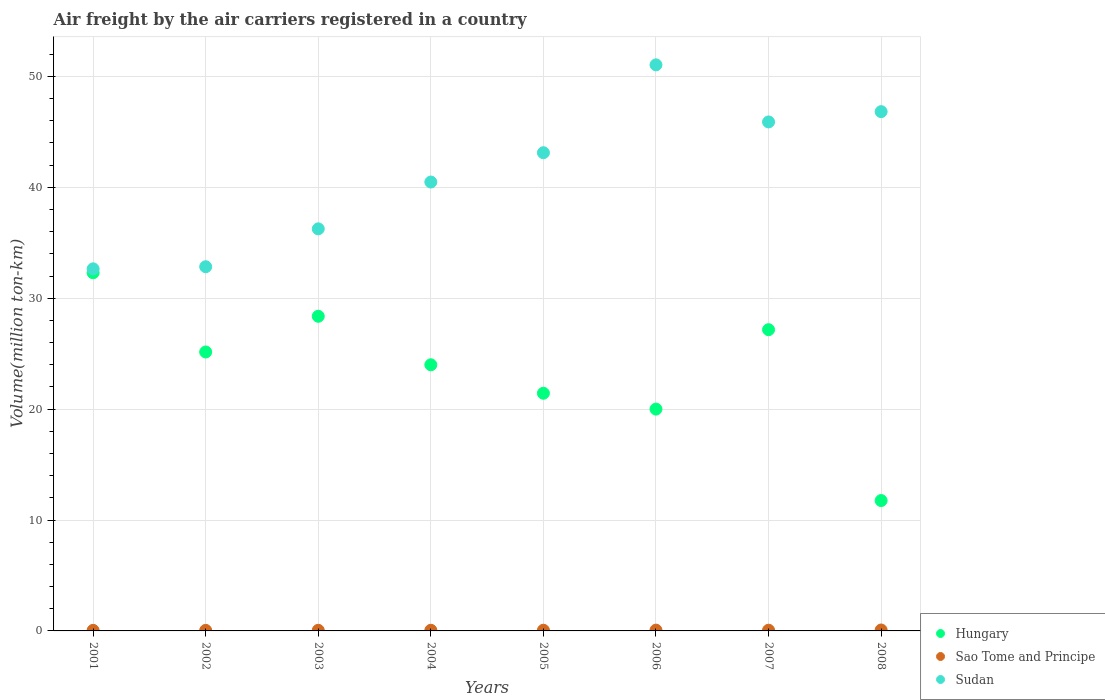What is the volume of the air carriers in Hungary in 2005?
Provide a succinct answer. 21.43. Across all years, what is the maximum volume of the air carriers in Sudan?
Offer a terse response. 51.04. Across all years, what is the minimum volume of the air carriers in Hungary?
Your answer should be compact. 11.76. In which year was the volume of the air carriers in Sudan minimum?
Ensure brevity in your answer.  2001. What is the total volume of the air carriers in Hungary in the graph?
Your response must be concise. 190.16. What is the difference between the volume of the air carriers in Hungary in 2002 and that in 2006?
Provide a succinct answer. 5.15. What is the difference between the volume of the air carriers in Hungary in 2006 and the volume of the air carriers in Sudan in 2003?
Provide a short and direct response. -16.25. What is the average volume of the air carriers in Hungary per year?
Give a very brief answer. 23.77. In the year 2001, what is the difference between the volume of the air carriers in Hungary and volume of the air carriers in Sao Tome and Principe?
Offer a terse response. 32.24. What is the ratio of the volume of the air carriers in Sao Tome and Principe in 2001 to that in 2005?
Your answer should be very brief. 0.82. Is the difference between the volume of the air carriers in Hungary in 2001 and 2007 greater than the difference between the volume of the air carriers in Sao Tome and Principe in 2001 and 2007?
Your response must be concise. Yes. What is the difference between the highest and the second highest volume of the air carriers in Hungary?
Keep it short and to the point. 3.92. What is the difference between the highest and the lowest volume of the air carriers in Sudan?
Offer a terse response. 18.39. Is the sum of the volume of the air carriers in Sudan in 2004 and 2008 greater than the maximum volume of the air carriers in Sao Tome and Principe across all years?
Make the answer very short. Yes. Does the volume of the air carriers in Sudan monotonically increase over the years?
Provide a short and direct response. No. Is the volume of the air carriers in Sudan strictly less than the volume of the air carriers in Hungary over the years?
Provide a succinct answer. No. How many dotlines are there?
Your answer should be very brief. 3. How many years are there in the graph?
Provide a short and direct response. 8. What is the difference between two consecutive major ticks on the Y-axis?
Your response must be concise. 10. Are the values on the major ticks of Y-axis written in scientific E-notation?
Give a very brief answer. No. Where does the legend appear in the graph?
Offer a terse response. Bottom right. How many legend labels are there?
Provide a short and direct response. 3. What is the title of the graph?
Make the answer very short. Air freight by the air carriers registered in a country. What is the label or title of the X-axis?
Your answer should be very brief. Years. What is the label or title of the Y-axis?
Provide a succinct answer. Volume(million ton-km). What is the Volume(million ton-km) of Hungary in 2001?
Ensure brevity in your answer.  32.29. What is the Volume(million ton-km) in Sao Tome and Principe in 2001?
Offer a very short reply. 0.05. What is the Volume(million ton-km) of Sudan in 2001?
Ensure brevity in your answer.  32.65. What is the Volume(million ton-km) of Hungary in 2002?
Give a very brief answer. 25.15. What is the Volume(million ton-km) of Sao Tome and Principe in 2002?
Your answer should be very brief. 0.05. What is the Volume(million ton-km) of Sudan in 2002?
Provide a succinct answer. 32.84. What is the Volume(million ton-km) in Hungary in 2003?
Provide a short and direct response. 28.37. What is the Volume(million ton-km) in Sao Tome and Principe in 2003?
Offer a very short reply. 0.06. What is the Volume(million ton-km) of Sudan in 2003?
Give a very brief answer. 36.25. What is the Volume(million ton-km) in Hungary in 2004?
Your response must be concise. 24. What is the Volume(million ton-km) in Sao Tome and Principe in 2004?
Your answer should be compact. 0.06. What is the Volume(million ton-km) of Sudan in 2004?
Keep it short and to the point. 40.47. What is the Volume(million ton-km) of Hungary in 2005?
Your answer should be compact. 21.43. What is the Volume(million ton-km) of Sao Tome and Principe in 2005?
Make the answer very short. 0.06. What is the Volume(million ton-km) in Sudan in 2005?
Your answer should be compact. 43.12. What is the Volume(million ton-km) of Sao Tome and Principe in 2006?
Offer a terse response. 0.07. What is the Volume(million ton-km) of Sudan in 2006?
Make the answer very short. 51.04. What is the Volume(million ton-km) in Hungary in 2007?
Ensure brevity in your answer.  27.16. What is the Volume(million ton-km) of Sao Tome and Principe in 2007?
Offer a very short reply. 0.06. What is the Volume(million ton-km) in Sudan in 2007?
Ensure brevity in your answer.  45.89. What is the Volume(million ton-km) in Hungary in 2008?
Your response must be concise. 11.76. What is the Volume(million ton-km) of Sao Tome and Principe in 2008?
Give a very brief answer. 0.08. What is the Volume(million ton-km) in Sudan in 2008?
Give a very brief answer. 46.82. Across all years, what is the maximum Volume(million ton-km) in Hungary?
Offer a very short reply. 32.29. Across all years, what is the maximum Volume(million ton-km) of Sao Tome and Principe?
Provide a succinct answer. 0.08. Across all years, what is the maximum Volume(million ton-km) in Sudan?
Make the answer very short. 51.04. Across all years, what is the minimum Volume(million ton-km) of Hungary?
Your answer should be very brief. 11.76. Across all years, what is the minimum Volume(million ton-km) of Sao Tome and Principe?
Make the answer very short. 0.05. Across all years, what is the minimum Volume(million ton-km) of Sudan?
Offer a very short reply. 32.65. What is the total Volume(million ton-km) in Hungary in the graph?
Provide a short and direct response. 190.16. What is the total Volume(million ton-km) in Sao Tome and Principe in the graph?
Offer a terse response. 0.5. What is the total Volume(million ton-km) in Sudan in the graph?
Ensure brevity in your answer.  329.08. What is the difference between the Volume(million ton-km) in Hungary in 2001 and that in 2002?
Give a very brief answer. 7.14. What is the difference between the Volume(million ton-km) in Sao Tome and Principe in 2001 and that in 2002?
Ensure brevity in your answer.  0. What is the difference between the Volume(million ton-km) in Sudan in 2001 and that in 2002?
Make the answer very short. -0.19. What is the difference between the Volume(million ton-km) of Hungary in 2001 and that in 2003?
Keep it short and to the point. 3.92. What is the difference between the Volume(million ton-km) in Sao Tome and Principe in 2001 and that in 2003?
Offer a very short reply. -0.01. What is the difference between the Volume(million ton-km) in Sudan in 2001 and that in 2003?
Provide a succinct answer. -3.61. What is the difference between the Volume(million ton-km) in Hungary in 2001 and that in 2004?
Your answer should be very brief. 8.3. What is the difference between the Volume(million ton-km) in Sao Tome and Principe in 2001 and that in 2004?
Provide a succinct answer. -0.01. What is the difference between the Volume(million ton-km) of Sudan in 2001 and that in 2004?
Your response must be concise. -7.83. What is the difference between the Volume(million ton-km) of Hungary in 2001 and that in 2005?
Keep it short and to the point. 10.87. What is the difference between the Volume(million ton-km) in Sao Tome and Principe in 2001 and that in 2005?
Make the answer very short. -0.01. What is the difference between the Volume(million ton-km) of Sudan in 2001 and that in 2005?
Your answer should be compact. -10.47. What is the difference between the Volume(million ton-km) of Hungary in 2001 and that in 2006?
Keep it short and to the point. 12.29. What is the difference between the Volume(million ton-km) in Sao Tome and Principe in 2001 and that in 2006?
Give a very brief answer. -0.02. What is the difference between the Volume(million ton-km) of Sudan in 2001 and that in 2006?
Your answer should be very brief. -18.39. What is the difference between the Volume(million ton-km) in Hungary in 2001 and that in 2007?
Make the answer very short. 5.13. What is the difference between the Volume(million ton-km) in Sao Tome and Principe in 2001 and that in 2007?
Ensure brevity in your answer.  -0.01. What is the difference between the Volume(million ton-km) in Sudan in 2001 and that in 2007?
Your answer should be very brief. -13.24. What is the difference between the Volume(million ton-km) in Hungary in 2001 and that in 2008?
Make the answer very short. 20.54. What is the difference between the Volume(million ton-km) in Sao Tome and Principe in 2001 and that in 2008?
Provide a succinct answer. -0.03. What is the difference between the Volume(million ton-km) of Sudan in 2001 and that in 2008?
Make the answer very short. -14.17. What is the difference between the Volume(million ton-km) of Hungary in 2002 and that in 2003?
Provide a succinct answer. -3.22. What is the difference between the Volume(million ton-km) in Sao Tome and Principe in 2002 and that in 2003?
Provide a short and direct response. -0.01. What is the difference between the Volume(million ton-km) in Sudan in 2002 and that in 2003?
Provide a short and direct response. -3.42. What is the difference between the Volume(million ton-km) of Hungary in 2002 and that in 2004?
Make the answer very short. 1.16. What is the difference between the Volume(million ton-km) in Sao Tome and Principe in 2002 and that in 2004?
Provide a short and direct response. -0.01. What is the difference between the Volume(million ton-km) of Sudan in 2002 and that in 2004?
Your answer should be very brief. -7.64. What is the difference between the Volume(million ton-km) of Hungary in 2002 and that in 2005?
Offer a terse response. 3.72. What is the difference between the Volume(million ton-km) in Sao Tome and Principe in 2002 and that in 2005?
Provide a short and direct response. -0.01. What is the difference between the Volume(million ton-km) in Sudan in 2002 and that in 2005?
Your answer should be very brief. -10.28. What is the difference between the Volume(million ton-km) of Hungary in 2002 and that in 2006?
Your response must be concise. 5.15. What is the difference between the Volume(million ton-km) in Sao Tome and Principe in 2002 and that in 2006?
Keep it short and to the point. -0.02. What is the difference between the Volume(million ton-km) of Sudan in 2002 and that in 2006?
Provide a short and direct response. -18.2. What is the difference between the Volume(million ton-km) in Hungary in 2002 and that in 2007?
Provide a succinct answer. -2.01. What is the difference between the Volume(million ton-km) in Sao Tome and Principe in 2002 and that in 2007?
Offer a very short reply. -0.01. What is the difference between the Volume(million ton-km) in Sudan in 2002 and that in 2007?
Your response must be concise. -13.05. What is the difference between the Volume(million ton-km) of Hungary in 2002 and that in 2008?
Ensure brevity in your answer.  13.4. What is the difference between the Volume(million ton-km) of Sao Tome and Principe in 2002 and that in 2008?
Ensure brevity in your answer.  -0.03. What is the difference between the Volume(million ton-km) in Sudan in 2002 and that in 2008?
Provide a short and direct response. -13.98. What is the difference between the Volume(million ton-km) in Hungary in 2003 and that in 2004?
Offer a very short reply. 4.37. What is the difference between the Volume(million ton-km) in Sao Tome and Principe in 2003 and that in 2004?
Provide a succinct answer. -0. What is the difference between the Volume(million ton-km) of Sudan in 2003 and that in 2004?
Provide a short and direct response. -4.22. What is the difference between the Volume(million ton-km) of Hungary in 2003 and that in 2005?
Offer a terse response. 6.94. What is the difference between the Volume(million ton-km) in Sao Tome and Principe in 2003 and that in 2005?
Make the answer very short. -0.01. What is the difference between the Volume(million ton-km) in Sudan in 2003 and that in 2005?
Make the answer very short. -6.86. What is the difference between the Volume(million ton-km) in Hungary in 2003 and that in 2006?
Your answer should be very brief. 8.37. What is the difference between the Volume(million ton-km) in Sao Tome and Principe in 2003 and that in 2006?
Offer a terse response. -0.01. What is the difference between the Volume(million ton-km) of Sudan in 2003 and that in 2006?
Your response must be concise. -14.79. What is the difference between the Volume(million ton-km) of Hungary in 2003 and that in 2007?
Offer a very short reply. 1.21. What is the difference between the Volume(million ton-km) in Sao Tome and Principe in 2003 and that in 2007?
Your answer should be very brief. -0.01. What is the difference between the Volume(million ton-km) in Sudan in 2003 and that in 2007?
Keep it short and to the point. -9.64. What is the difference between the Volume(million ton-km) of Hungary in 2003 and that in 2008?
Your answer should be compact. 16.61. What is the difference between the Volume(million ton-km) of Sao Tome and Principe in 2003 and that in 2008?
Keep it short and to the point. -0.03. What is the difference between the Volume(million ton-km) in Sudan in 2003 and that in 2008?
Give a very brief answer. -10.57. What is the difference between the Volume(million ton-km) of Hungary in 2004 and that in 2005?
Offer a terse response. 2.57. What is the difference between the Volume(million ton-km) in Sao Tome and Principe in 2004 and that in 2005?
Make the answer very short. -0. What is the difference between the Volume(million ton-km) of Sudan in 2004 and that in 2005?
Make the answer very short. -2.64. What is the difference between the Volume(million ton-km) of Hungary in 2004 and that in 2006?
Offer a very short reply. 4. What is the difference between the Volume(million ton-km) in Sao Tome and Principe in 2004 and that in 2006?
Your answer should be compact. -0.01. What is the difference between the Volume(million ton-km) in Sudan in 2004 and that in 2006?
Your response must be concise. -10.57. What is the difference between the Volume(million ton-km) of Hungary in 2004 and that in 2007?
Provide a short and direct response. -3.17. What is the difference between the Volume(million ton-km) of Sao Tome and Principe in 2004 and that in 2007?
Give a very brief answer. -0.01. What is the difference between the Volume(million ton-km) of Sudan in 2004 and that in 2007?
Ensure brevity in your answer.  -5.42. What is the difference between the Volume(million ton-km) in Hungary in 2004 and that in 2008?
Provide a short and direct response. 12.24. What is the difference between the Volume(million ton-km) of Sao Tome and Principe in 2004 and that in 2008?
Offer a terse response. -0.03. What is the difference between the Volume(million ton-km) of Sudan in 2004 and that in 2008?
Your answer should be compact. -6.35. What is the difference between the Volume(million ton-km) in Hungary in 2005 and that in 2006?
Give a very brief answer. 1.43. What is the difference between the Volume(million ton-km) in Sao Tome and Principe in 2005 and that in 2006?
Offer a terse response. -0.01. What is the difference between the Volume(million ton-km) of Sudan in 2005 and that in 2006?
Make the answer very short. -7.92. What is the difference between the Volume(million ton-km) in Hungary in 2005 and that in 2007?
Provide a short and direct response. -5.73. What is the difference between the Volume(million ton-km) of Sao Tome and Principe in 2005 and that in 2007?
Offer a very short reply. -0. What is the difference between the Volume(million ton-km) in Sudan in 2005 and that in 2007?
Provide a short and direct response. -2.77. What is the difference between the Volume(million ton-km) in Hungary in 2005 and that in 2008?
Keep it short and to the point. 9.67. What is the difference between the Volume(million ton-km) in Sao Tome and Principe in 2005 and that in 2008?
Give a very brief answer. -0.02. What is the difference between the Volume(million ton-km) of Sudan in 2005 and that in 2008?
Give a very brief answer. -3.7. What is the difference between the Volume(million ton-km) of Hungary in 2006 and that in 2007?
Provide a short and direct response. -7.16. What is the difference between the Volume(million ton-km) in Sao Tome and Principe in 2006 and that in 2007?
Ensure brevity in your answer.  0.01. What is the difference between the Volume(million ton-km) of Sudan in 2006 and that in 2007?
Your answer should be very brief. 5.15. What is the difference between the Volume(million ton-km) of Hungary in 2006 and that in 2008?
Give a very brief answer. 8.24. What is the difference between the Volume(million ton-km) in Sao Tome and Principe in 2006 and that in 2008?
Ensure brevity in your answer.  -0.01. What is the difference between the Volume(million ton-km) in Sudan in 2006 and that in 2008?
Make the answer very short. 4.22. What is the difference between the Volume(million ton-km) of Hungary in 2007 and that in 2008?
Your answer should be very brief. 15.41. What is the difference between the Volume(million ton-km) in Sao Tome and Principe in 2007 and that in 2008?
Offer a very short reply. -0.02. What is the difference between the Volume(million ton-km) in Sudan in 2007 and that in 2008?
Offer a very short reply. -0.93. What is the difference between the Volume(million ton-km) in Hungary in 2001 and the Volume(million ton-km) in Sao Tome and Principe in 2002?
Give a very brief answer. 32.24. What is the difference between the Volume(million ton-km) of Hungary in 2001 and the Volume(million ton-km) of Sudan in 2002?
Ensure brevity in your answer.  -0.54. What is the difference between the Volume(million ton-km) in Sao Tome and Principe in 2001 and the Volume(million ton-km) in Sudan in 2002?
Keep it short and to the point. -32.79. What is the difference between the Volume(million ton-km) of Hungary in 2001 and the Volume(million ton-km) of Sao Tome and Principe in 2003?
Your answer should be very brief. 32.24. What is the difference between the Volume(million ton-km) of Hungary in 2001 and the Volume(million ton-km) of Sudan in 2003?
Your answer should be compact. -3.96. What is the difference between the Volume(million ton-km) in Sao Tome and Principe in 2001 and the Volume(million ton-km) in Sudan in 2003?
Provide a short and direct response. -36.2. What is the difference between the Volume(million ton-km) in Hungary in 2001 and the Volume(million ton-km) in Sao Tome and Principe in 2004?
Make the answer very short. 32.23. What is the difference between the Volume(million ton-km) in Hungary in 2001 and the Volume(million ton-km) in Sudan in 2004?
Your response must be concise. -8.18. What is the difference between the Volume(million ton-km) of Sao Tome and Principe in 2001 and the Volume(million ton-km) of Sudan in 2004?
Make the answer very short. -40.42. What is the difference between the Volume(million ton-km) in Hungary in 2001 and the Volume(million ton-km) in Sao Tome and Principe in 2005?
Provide a succinct answer. 32.23. What is the difference between the Volume(million ton-km) in Hungary in 2001 and the Volume(million ton-km) in Sudan in 2005?
Offer a very short reply. -10.82. What is the difference between the Volume(million ton-km) of Sao Tome and Principe in 2001 and the Volume(million ton-km) of Sudan in 2005?
Your response must be concise. -43.07. What is the difference between the Volume(million ton-km) in Hungary in 2001 and the Volume(million ton-km) in Sao Tome and Principe in 2006?
Offer a very short reply. 32.22. What is the difference between the Volume(million ton-km) in Hungary in 2001 and the Volume(million ton-km) in Sudan in 2006?
Make the answer very short. -18.75. What is the difference between the Volume(million ton-km) of Sao Tome and Principe in 2001 and the Volume(million ton-km) of Sudan in 2006?
Offer a very short reply. -50.99. What is the difference between the Volume(million ton-km) of Hungary in 2001 and the Volume(million ton-km) of Sao Tome and Principe in 2007?
Offer a terse response. 32.23. What is the difference between the Volume(million ton-km) in Hungary in 2001 and the Volume(million ton-km) in Sudan in 2007?
Offer a terse response. -13.6. What is the difference between the Volume(million ton-km) in Sao Tome and Principe in 2001 and the Volume(million ton-km) in Sudan in 2007?
Your answer should be compact. -45.84. What is the difference between the Volume(million ton-km) of Hungary in 2001 and the Volume(million ton-km) of Sao Tome and Principe in 2008?
Make the answer very short. 32.21. What is the difference between the Volume(million ton-km) in Hungary in 2001 and the Volume(million ton-km) in Sudan in 2008?
Provide a short and direct response. -14.53. What is the difference between the Volume(million ton-km) in Sao Tome and Principe in 2001 and the Volume(million ton-km) in Sudan in 2008?
Provide a short and direct response. -46.77. What is the difference between the Volume(million ton-km) in Hungary in 2002 and the Volume(million ton-km) in Sao Tome and Principe in 2003?
Give a very brief answer. 25.09. What is the difference between the Volume(million ton-km) in Hungary in 2002 and the Volume(million ton-km) in Sudan in 2003?
Your answer should be compact. -11.1. What is the difference between the Volume(million ton-km) of Sao Tome and Principe in 2002 and the Volume(million ton-km) of Sudan in 2003?
Provide a short and direct response. -36.2. What is the difference between the Volume(million ton-km) of Hungary in 2002 and the Volume(million ton-km) of Sao Tome and Principe in 2004?
Your answer should be very brief. 25.09. What is the difference between the Volume(million ton-km) of Hungary in 2002 and the Volume(million ton-km) of Sudan in 2004?
Keep it short and to the point. -15.32. What is the difference between the Volume(million ton-km) of Sao Tome and Principe in 2002 and the Volume(million ton-km) of Sudan in 2004?
Offer a terse response. -40.42. What is the difference between the Volume(million ton-km) in Hungary in 2002 and the Volume(million ton-km) in Sao Tome and Principe in 2005?
Offer a very short reply. 25.09. What is the difference between the Volume(million ton-km) of Hungary in 2002 and the Volume(million ton-km) of Sudan in 2005?
Give a very brief answer. -17.97. What is the difference between the Volume(million ton-km) of Sao Tome and Principe in 2002 and the Volume(million ton-km) of Sudan in 2005?
Keep it short and to the point. -43.07. What is the difference between the Volume(million ton-km) in Hungary in 2002 and the Volume(million ton-km) in Sao Tome and Principe in 2006?
Give a very brief answer. 25.08. What is the difference between the Volume(million ton-km) of Hungary in 2002 and the Volume(million ton-km) of Sudan in 2006?
Your answer should be very brief. -25.89. What is the difference between the Volume(million ton-km) of Sao Tome and Principe in 2002 and the Volume(million ton-km) of Sudan in 2006?
Your answer should be compact. -50.99. What is the difference between the Volume(million ton-km) of Hungary in 2002 and the Volume(million ton-km) of Sao Tome and Principe in 2007?
Ensure brevity in your answer.  25.09. What is the difference between the Volume(million ton-km) in Hungary in 2002 and the Volume(million ton-km) in Sudan in 2007?
Give a very brief answer. -20.74. What is the difference between the Volume(million ton-km) in Sao Tome and Principe in 2002 and the Volume(million ton-km) in Sudan in 2007?
Ensure brevity in your answer.  -45.84. What is the difference between the Volume(million ton-km) in Hungary in 2002 and the Volume(million ton-km) in Sao Tome and Principe in 2008?
Give a very brief answer. 25.07. What is the difference between the Volume(million ton-km) of Hungary in 2002 and the Volume(million ton-km) of Sudan in 2008?
Provide a succinct answer. -21.67. What is the difference between the Volume(million ton-km) of Sao Tome and Principe in 2002 and the Volume(million ton-km) of Sudan in 2008?
Ensure brevity in your answer.  -46.77. What is the difference between the Volume(million ton-km) of Hungary in 2003 and the Volume(million ton-km) of Sao Tome and Principe in 2004?
Provide a succinct answer. 28.31. What is the difference between the Volume(million ton-km) of Hungary in 2003 and the Volume(million ton-km) of Sudan in 2004?
Offer a terse response. -12.1. What is the difference between the Volume(million ton-km) of Sao Tome and Principe in 2003 and the Volume(million ton-km) of Sudan in 2004?
Make the answer very short. -40.42. What is the difference between the Volume(million ton-km) in Hungary in 2003 and the Volume(million ton-km) in Sao Tome and Principe in 2005?
Provide a succinct answer. 28.31. What is the difference between the Volume(million ton-km) of Hungary in 2003 and the Volume(million ton-km) of Sudan in 2005?
Offer a terse response. -14.75. What is the difference between the Volume(million ton-km) of Sao Tome and Principe in 2003 and the Volume(million ton-km) of Sudan in 2005?
Provide a short and direct response. -43.06. What is the difference between the Volume(million ton-km) in Hungary in 2003 and the Volume(million ton-km) in Sao Tome and Principe in 2006?
Your response must be concise. 28.3. What is the difference between the Volume(million ton-km) of Hungary in 2003 and the Volume(million ton-km) of Sudan in 2006?
Provide a short and direct response. -22.67. What is the difference between the Volume(million ton-km) in Sao Tome and Principe in 2003 and the Volume(million ton-km) in Sudan in 2006?
Give a very brief answer. -50.98. What is the difference between the Volume(million ton-km) of Hungary in 2003 and the Volume(million ton-km) of Sao Tome and Principe in 2007?
Give a very brief answer. 28.31. What is the difference between the Volume(million ton-km) of Hungary in 2003 and the Volume(million ton-km) of Sudan in 2007?
Provide a succinct answer. -17.52. What is the difference between the Volume(million ton-km) of Sao Tome and Principe in 2003 and the Volume(million ton-km) of Sudan in 2007?
Provide a succinct answer. -45.84. What is the difference between the Volume(million ton-km) in Hungary in 2003 and the Volume(million ton-km) in Sao Tome and Principe in 2008?
Your answer should be compact. 28.29. What is the difference between the Volume(million ton-km) of Hungary in 2003 and the Volume(million ton-km) of Sudan in 2008?
Your response must be concise. -18.45. What is the difference between the Volume(million ton-km) in Sao Tome and Principe in 2003 and the Volume(million ton-km) in Sudan in 2008?
Give a very brief answer. -46.77. What is the difference between the Volume(million ton-km) of Hungary in 2004 and the Volume(million ton-km) of Sao Tome and Principe in 2005?
Your answer should be very brief. 23.93. What is the difference between the Volume(million ton-km) of Hungary in 2004 and the Volume(million ton-km) of Sudan in 2005?
Your answer should be very brief. -19.12. What is the difference between the Volume(million ton-km) in Sao Tome and Principe in 2004 and the Volume(million ton-km) in Sudan in 2005?
Your response must be concise. -43.06. What is the difference between the Volume(million ton-km) in Hungary in 2004 and the Volume(million ton-km) in Sao Tome and Principe in 2006?
Provide a short and direct response. 23.93. What is the difference between the Volume(million ton-km) in Hungary in 2004 and the Volume(million ton-km) in Sudan in 2006?
Give a very brief answer. -27.04. What is the difference between the Volume(million ton-km) in Sao Tome and Principe in 2004 and the Volume(million ton-km) in Sudan in 2006?
Keep it short and to the point. -50.98. What is the difference between the Volume(million ton-km) in Hungary in 2004 and the Volume(million ton-km) in Sao Tome and Principe in 2007?
Your answer should be very brief. 23.93. What is the difference between the Volume(million ton-km) of Hungary in 2004 and the Volume(million ton-km) of Sudan in 2007?
Your response must be concise. -21.9. What is the difference between the Volume(million ton-km) of Sao Tome and Principe in 2004 and the Volume(million ton-km) of Sudan in 2007?
Provide a succinct answer. -45.83. What is the difference between the Volume(million ton-km) of Hungary in 2004 and the Volume(million ton-km) of Sao Tome and Principe in 2008?
Ensure brevity in your answer.  23.91. What is the difference between the Volume(million ton-km) in Hungary in 2004 and the Volume(million ton-km) in Sudan in 2008?
Keep it short and to the point. -22.82. What is the difference between the Volume(million ton-km) of Sao Tome and Principe in 2004 and the Volume(million ton-km) of Sudan in 2008?
Offer a terse response. -46.76. What is the difference between the Volume(million ton-km) in Hungary in 2005 and the Volume(million ton-km) in Sao Tome and Principe in 2006?
Give a very brief answer. 21.36. What is the difference between the Volume(million ton-km) in Hungary in 2005 and the Volume(million ton-km) in Sudan in 2006?
Give a very brief answer. -29.61. What is the difference between the Volume(million ton-km) in Sao Tome and Principe in 2005 and the Volume(million ton-km) in Sudan in 2006?
Your response must be concise. -50.98. What is the difference between the Volume(million ton-km) of Hungary in 2005 and the Volume(million ton-km) of Sao Tome and Principe in 2007?
Give a very brief answer. 21.36. What is the difference between the Volume(million ton-km) of Hungary in 2005 and the Volume(million ton-km) of Sudan in 2007?
Ensure brevity in your answer.  -24.46. What is the difference between the Volume(million ton-km) in Sao Tome and Principe in 2005 and the Volume(million ton-km) in Sudan in 2007?
Your answer should be very brief. -45.83. What is the difference between the Volume(million ton-km) in Hungary in 2005 and the Volume(million ton-km) in Sao Tome and Principe in 2008?
Keep it short and to the point. 21.34. What is the difference between the Volume(million ton-km) of Hungary in 2005 and the Volume(million ton-km) of Sudan in 2008?
Your answer should be compact. -25.39. What is the difference between the Volume(million ton-km) in Sao Tome and Principe in 2005 and the Volume(million ton-km) in Sudan in 2008?
Provide a succinct answer. -46.76. What is the difference between the Volume(million ton-km) of Hungary in 2006 and the Volume(million ton-km) of Sao Tome and Principe in 2007?
Provide a short and direct response. 19.94. What is the difference between the Volume(million ton-km) in Hungary in 2006 and the Volume(million ton-km) in Sudan in 2007?
Your response must be concise. -25.89. What is the difference between the Volume(million ton-km) in Sao Tome and Principe in 2006 and the Volume(million ton-km) in Sudan in 2007?
Ensure brevity in your answer.  -45.82. What is the difference between the Volume(million ton-km) in Hungary in 2006 and the Volume(million ton-km) in Sao Tome and Principe in 2008?
Give a very brief answer. 19.92. What is the difference between the Volume(million ton-km) in Hungary in 2006 and the Volume(million ton-km) in Sudan in 2008?
Your answer should be very brief. -26.82. What is the difference between the Volume(million ton-km) in Sao Tome and Principe in 2006 and the Volume(million ton-km) in Sudan in 2008?
Your answer should be compact. -46.75. What is the difference between the Volume(million ton-km) of Hungary in 2007 and the Volume(million ton-km) of Sao Tome and Principe in 2008?
Provide a short and direct response. 27.08. What is the difference between the Volume(million ton-km) in Hungary in 2007 and the Volume(million ton-km) in Sudan in 2008?
Give a very brief answer. -19.66. What is the difference between the Volume(million ton-km) in Sao Tome and Principe in 2007 and the Volume(million ton-km) in Sudan in 2008?
Your response must be concise. -46.76. What is the average Volume(million ton-km) in Hungary per year?
Offer a terse response. 23.77. What is the average Volume(million ton-km) in Sao Tome and Principe per year?
Provide a short and direct response. 0.06. What is the average Volume(million ton-km) in Sudan per year?
Your answer should be very brief. 41.14. In the year 2001, what is the difference between the Volume(million ton-km) in Hungary and Volume(million ton-km) in Sao Tome and Principe?
Give a very brief answer. 32.24. In the year 2001, what is the difference between the Volume(million ton-km) of Hungary and Volume(million ton-km) of Sudan?
Provide a succinct answer. -0.35. In the year 2001, what is the difference between the Volume(million ton-km) of Sao Tome and Principe and Volume(million ton-km) of Sudan?
Keep it short and to the point. -32.6. In the year 2002, what is the difference between the Volume(million ton-km) in Hungary and Volume(million ton-km) in Sao Tome and Principe?
Make the answer very short. 25.1. In the year 2002, what is the difference between the Volume(million ton-km) in Hungary and Volume(million ton-km) in Sudan?
Provide a short and direct response. -7.69. In the year 2002, what is the difference between the Volume(million ton-km) in Sao Tome and Principe and Volume(million ton-km) in Sudan?
Provide a succinct answer. -32.79. In the year 2003, what is the difference between the Volume(million ton-km) of Hungary and Volume(million ton-km) of Sao Tome and Principe?
Your answer should be very brief. 28.31. In the year 2003, what is the difference between the Volume(million ton-km) of Hungary and Volume(million ton-km) of Sudan?
Offer a very short reply. -7.88. In the year 2003, what is the difference between the Volume(million ton-km) in Sao Tome and Principe and Volume(million ton-km) in Sudan?
Your answer should be very brief. -36.2. In the year 2004, what is the difference between the Volume(million ton-km) in Hungary and Volume(million ton-km) in Sao Tome and Principe?
Ensure brevity in your answer.  23.94. In the year 2004, what is the difference between the Volume(million ton-km) in Hungary and Volume(million ton-km) in Sudan?
Make the answer very short. -16.48. In the year 2004, what is the difference between the Volume(million ton-km) of Sao Tome and Principe and Volume(million ton-km) of Sudan?
Your answer should be very brief. -40.41. In the year 2005, what is the difference between the Volume(million ton-km) of Hungary and Volume(million ton-km) of Sao Tome and Principe?
Provide a short and direct response. 21.37. In the year 2005, what is the difference between the Volume(million ton-km) in Hungary and Volume(million ton-km) in Sudan?
Offer a very short reply. -21.69. In the year 2005, what is the difference between the Volume(million ton-km) in Sao Tome and Principe and Volume(million ton-km) in Sudan?
Make the answer very short. -43.06. In the year 2006, what is the difference between the Volume(million ton-km) of Hungary and Volume(million ton-km) of Sao Tome and Principe?
Ensure brevity in your answer.  19.93. In the year 2006, what is the difference between the Volume(million ton-km) in Hungary and Volume(million ton-km) in Sudan?
Offer a terse response. -31.04. In the year 2006, what is the difference between the Volume(million ton-km) of Sao Tome and Principe and Volume(million ton-km) of Sudan?
Keep it short and to the point. -50.97. In the year 2007, what is the difference between the Volume(million ton-km) of Hungary and Volume(million ton-km) of Sao Tome and Principe?
Offer a terse response. 27.1. In the year 2007, what is the difference between the Volume(million ton-km) of Hungary and Volume(million ton-km) of Sudan?
Make the answer very short. -18.73. In the year 2007, what is the difference between the Volume(million ton-km) in Sao Tome and Principe and Volume(million ton-km) in Sudan?
Make the answer very short. -45.83. In the year 2008, what is the difference between the Volume(million ton-km) of Hungary and Volume(million ton-km) of Sao Tome and Principe?
Provide a succinct answer. 11.67. In the year 2008, what is the difference between the Volume(million ton-km) in Hungary and Volume(million ton-km) in Sudan?
Keep it short and to the point. -35.07. In the year 2008, what is the difference between the Volume(million ton-km) in Sao Tome and Principe and Volume(million ton-km) in Sudan?
Offer a very short reply. -46.74. What is the ratio of the Volume(million ton-km) in Hungary in 2001 to that in 2002?
Provide a short and direct response. 1.28. What is the ratio of the Volume(million ton-km) of Hungary in 2001 to that in 2003?
Keep it short and to the point. 1.14. What is the ratio of the Volume(million ton-km) in Sao Tome and Principe in 2001 to that in 2003?
Make the answer very short. 0.91. What is the ratio of the Volume(million ton-km) of Sudan in 2001 to that in 2003?
Give a very brief answer. 0.9. What is the ratio of the Volume(million ton-km) of Hungary in 2001 to that in 2004?
Your answer should be very brief. 1.35. What is the ratio of the Volume(million ton-km) of Sao Tome and Principe in 2001 to that in 2004?
Offer a very short reply. 0.86. What is the ratio of the Volume(million ton-km) in Sudan in 2001 to that in 2004?
Offer a terse response. 0.81. What is the ratio of the Volume(million ton-km) in Hungary in 2001 to that in 2005?
Give a very brief answer. 1.51. What is the ratio of the Volume(million ton-km) in Sao Tome and Principe in 2001 to that in 2005?
Offer a terse response. 0.82. What is the ratio of the Volume(million ton-km) of Sudan in 2001 to that in 2005?
Your response must be concise. 0.76. What is the ratio of the Volume(million ton-km) in Hungary in 2001 to that in 2006?
Your answer should be compact. 1.61. What is the ratio of the Volume(million ton-km) in Sao Tome and Principe in 2001 to that in 2006?
Your answer should be compact. 0.72. What is the ratio of the Volume(million ton-km) of Sudan in 2001 to that in 2006?
Your response must be concise. 0.64. What is the ratio of the Volume(million ton-km) in Hungary in 2001 to that in 2007?
Your answer should be compact. 1.19. What is the ratio of the Volume(million ton-km) in Sao Tome and Principe in 2001 to that in 2007?
Your response must be concise. 0.8. What is the ratio of the Volume(million ton-km) in Sudan in 2001 to that in 2007?
Provide a succinct answer. 0.71. What is the ratio of the Volume(million ton-km) of Hungary in 2001 to that in 2008?
Offer a very short reply. 2.75. What is the ratio of the Volume(million ton-km) in Sao Tome and Principe in 2001 to that in 2008?
Offer a very short reply. 0.61. What is the ratio of the Volume(million ton-km) of Sudan in 2001 to that in 2008?
Make the answer very short. 0.7. What is the ratio of the Volume(million ton-km) of Hungary in 2002 to that in 2003?
Your answer should be very brief. 0.89. What is the ratio of the Volume(million ton-km) in Sao Tome and Principe in 2002 to that in 2003?
Your answer should be very brief. 0.89. What is the ratio of the Volume(million ton-km) in Sudan in 2002 to that in 2003?
Provide a short and direct response. 0.91. What is the ratio of the Volume(million ton-km) in Hungary in 2002 to that in 2004?
Your response must be concise. 1.05. What is the ratio of the Volume(million ton-km) of Sao Tome and Principe in 2002 to that in 2004?
Keep it short and to the point. 0.85. What is the ratio of the Volume(million ton-km) of Sudan in 2002 to that in 2004?
Give a very brief answer. 0.81. What is the ratio of the Volume(million ton-km) of Hungary in 2002 to that in 2005?
Your answer should be compact. 1.17. What is the ratio of the Volume(million ton-km) in Sao Tome and Principe in 2002 to that in 2005?
Provide a short and direct response. 0.81. What is the ratio of the Volume(million ton-km) of Sudan in 2002 to that in 2005?
Provide a short and direct response. 0.76. What is the ratio of the Volume(million ton-km) of Hungary in 2002 to that in 2006?
Your answer should be very brief. 1.26. What is the ratio of the Volume(million ton-km) in Sao Tome and Principe in 2002 to that in 2006?
Your answer should be very brief. 0.7. What is the ratio of the Volume(million ton-km) in Sudan in 2002 to that in 2006?
Provide a short and direct response. 0.64. What is the ratio of the Volume(million ton-km) in Hungary in 2002 to that in 2007?
Your answer should be very brief. 0.93. What is the ratio of the Volume(million ton-km) of Sao Tome and Principe in 2002 to that in 2007?
Provide a succinct answer. 0.78. What is the ratio of the Volume(million ton-km) in Sudan in 2002 to that in 2007?
Make the answer very short. 0.72. What is the ratio of the Volume(million ton-km) of Hungary in 2002 to that in 2008?
Your answer should be very brief. 2.14. What is the ratio of the Volume(million ton-km) in Sao Tome and Principe in 2002 to that in 2008?
Your answer should be compact. 0.6. What is the ratio of the Volume(million ton-km) in Sudan in 2002 to that in 2008?
Your answer should be very brief. 0.7. What is the ratio of the Volume(million ton-km) of Hungary in 2003 to that in 2004?
Your response must be concise. 1.18. What is the ratio of the Volume(million ton-km) in Sao Tome and Principe in 2003 to that in 2004?
Your answer should be very brief. 0.95. What is the ratio of the Volume(million ton-km) of Sudan in 2003 to that in 2004?
Ensure brevity in your answer.  0.9. What is the ratio of the Volume(million ton-km) of Hungary in 2003 to that in 2005?
Keep it short and to the point. 1.32. What is the ratio of the Volume(million ton-km) in Sao Tome and Principe in 2003 to that in 2005?
Offer a terse response. 0.9. What is the ratio of the Volume(million ton-km) in Sudan in 2003 to that in 2005?
Offer a terse response. 0.84. What is the ratio of the Volume(million ton-km) of Hungary in 2003 to that in 2006?
Provide a short and direct response. 1.42. What is the ratio of the Volume(million ton-km) of Sao Tome and Principe in 2003 to that in 2006?
Give a very brief answer. 0.79. What is the ratio of the Volume(million ton-km) of Sudan in 2003 to that in 2006?
Ensure brevity in your answer.  0.71. What is the ratio of the Volume(million ton-km) in Hungary in 2003 to that in 2007?
Give a very brief answer. 1.04. What is the ratio of the Volume(million ton-km) in Sudan in 2003 to that in 2007?
Offer a terse response. 0.79. What is the ratio of the Volume(million ton-km) in Hungary in 2003 to that in 2008?
Keep it short and to the point. 2.41. What is the ratio of the Volume(million ton-km) in Sao Tome and Principe in 2003 to that in 2008?
Provide a short and direct response. 0.67. What is the ratio of the Volume(million ton-km) of Sudan in 2003 to that in 2008?
Provide a short and direct response. 0.77. What is the ratio of the Volume(million ton-km) in Hungary in 2004 to that in 2005?
Keep it short and to the point. 1.12. What is the ratio of the Volume(million ton-km) in Sao Tome and Principe in 2004 to that in 2005?
Offer a terse response. 0.95. What is the ratio of the Volume(million ton-km) of Sudan in 2004 to that in 2005?
Provide a short and direct response. 0.94. What is the ratio of the Volume(million ton-km) of Hungary in 2004 to that in 2006?
Your response must be concise. 1.2. What is the ratio of the Volume(million ton-km) in Sao Tome and Principe in 2004 to that in 2006?
Keep it short and to the point. 0.83. What is the ratio of the Volume(million ton-km) of Sudan in 2004 to that in 2006?
Ensure brevity in your answer.  0.79. What is the ratio of the Volume(million ton-km) of Hungary in 2004 to that in 2007?
Your answer should be compact. 0.88. What is the ratio of the Volume(million ton-km) of Sao Tome and Principe in 2004 to that in 2007?
Provide a succinct answer. 0.92. What is the ratio of the Volume(million ton-km) of Sudan in 2004 to that in 2007?
Your answer should be very brief. 0.88. What is the ratio of the Volume(million ton-km) of Hungary in 2004 to that in 2008?
Ensure brevity in your answer.  2.04. What is the ratio of the Volume(million ton-km) of Sao Tome and Principe in 2004 to that in 2008?
Your answer should be compact. 0.7. What is the ratio of the Volume(million ton-km) in Sudan in 2004 to that in 2008?
Provide a short and direct response. 0.86. What is the ratio of the Volume(million ton-km) of Hungary in 2005 to that in 2006?
Make the answer very short. 1.07. What is the ratio of the Volume(million ton-km) in Sao Tome and Principe in 2005 to that in 2006?
Provide a short and direct response. 0.87. What is the ratio of the Volume(million ton-km) in Sudan in 2005 to that in 2006?
Offer a terse response. 0.84. What is the ratio of the Volume(million ton-km) of Hungary in 2005 to that in 2007?
Offer a terse response. 0.79. What is the ratio of the Volume(million ton-km) of Sao Tome and Principe in 2005 to that in 2007?
Make the answer very short. 0.97. What is the ratio of the Volume(million ton-km) in Sudan in 2005 to that in 2007?
Offer a very short reply. 0.94. What is the ratio of the Volume(million ton-km) of Hungary in 2005 to that in 2008?
Provide a succinct answer. 1.82. What is the ratio of the Volume(million ton-km) of Sao Tome and Principe in 2005 to that in 2008?
Offer a very short reply. 0.74. What is the ratio of the Volume(million ton-km) of Sudan in 2005 to that in 2008?
Your answer should be very brief. 0.92. What is the ratio of the Volume(million ton-km) of Hungary in 2006 to that in 2007?
Keep it short and to the point. 0.74. What is the ratio of the Volume(million ton-km) of Sao Tome and Principe in 2006 to that in 2007?
Offer a very short reply. 1.11. What is the ratio of the Volume(million ton-km) in Sudan in 2006 to that in 2007?
Your response must be concise. 1.11. What is the ratio of the Volume(million ton-km) of Hungary in 2006 to that in 2008?
Offer a terse response. 1.7. What is the ratio of the Volume(million ton-km) in Sao Tome and Principe in 2006 to that in 2008?
Your response must be concise. 0.85. What is the ratio of the Volume(million ton-km) in Sudan in 2006 to that in 2008?
Provide a succinct answer. 1.09. What is the ratio of the Volume(million ton-km) of Hungary in 2007 to that in 2008?
Keep it short and to the point. 2.31. What is the ratio of the Volume(million ton-km) of Sao Tome and Principe in 2007 to that in 2008?
Offer a very short reply. 0.76. What is the ratio of the Volume(million ton-km) in Sudan in 2007 to that in 2008?
Keep it short and to the point. 0.98. What is the difference between the highest and the second highest Volume(million ton-km) of Hungary?
Your answer should be compact. 3.92. What is the difference between the highest and the second highest Volume(million ton-km) in Sao Tome and Principe?
Provide a short and direct response. 0.01. What is the difference between the highest and the second highest Volume(million ton-km) in Sudan?
Provide a succinct answer. 4.22. What is the difference between the highest and the lowest Volume(million ton-km) of Hungary?
Ensure brevity in your answer.  20.54. What is the difference between the highest and the lowest Volume(million ton-km) of Sao Tome and Principe?
Your answer should be compact. 0.03. What is the difference between the highest and the lowest Volume(million ton-km) in Sudan?
Offer a very short reply. 18.39. 